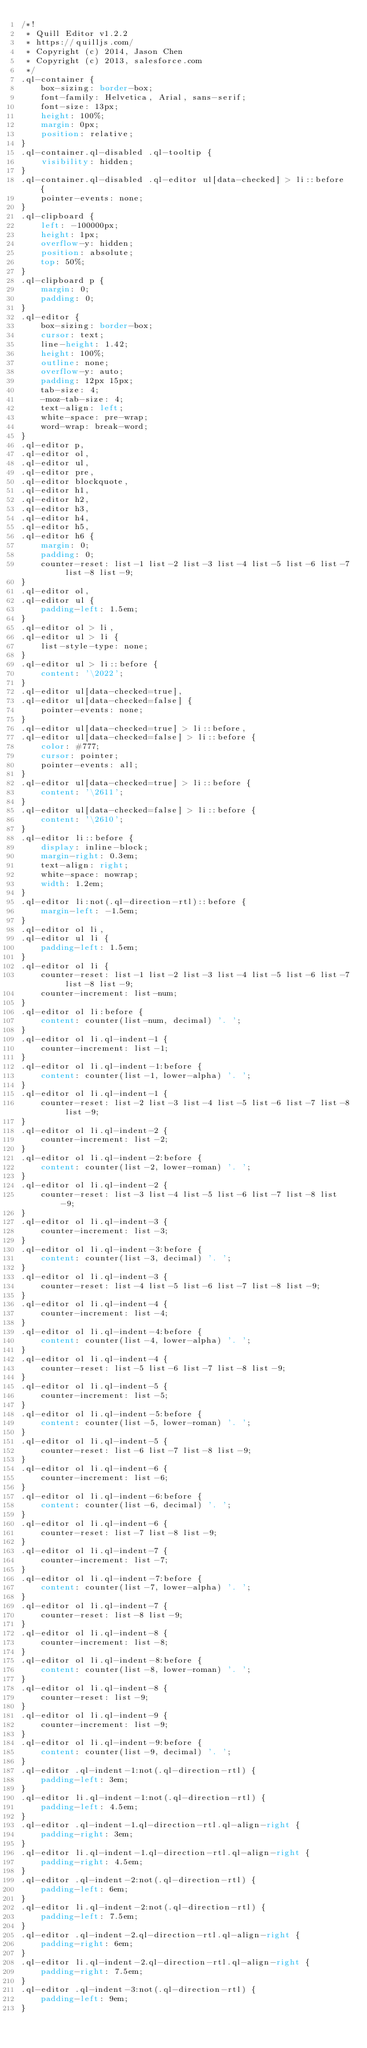<code> <loc_0><loc_0><loc_500><loc_500><_CSS_>/*!
 * Quill Editor v1.2.2
 * https://quilljs.com/
 * Copyright (c) 2014, Jason Chen
 * Copyright (c) 2013, salesforce.com
 */
.ql-container {
    box-sizing: border-box;
    font-family: Helvetica, Arial, sans-serif;
    font-size: 13px;
    height: 100%;
    margin: 0px;
    position: relative;
}
.ql-container.ql-disabled .ql-tooltip {
    visibility: hidden;
}
.ql-container.ql-disabled .ql-editor ul[data-checked] > li::before {
    pointer-events: none;
}
.ql-clipboard {
    left: -100000px;
    height: 1px;
    overflow-y: hidden;
    position: absolute;
    top: 50%;
}
.ql-clipboard p {
    margin: 0;
    padding: 0;
}
.ql-editor {
    box-sizing: border-box;
    cursor: text;
    line-height: 1.42;
    height: 100%;
    outline: none;
    overflow-y: auto;
    padding: 12px 15px;
    tab-size: 4;
    -moz-tab-size: 4;
    text-align: left;
    white-space: pre-wrap;
    word-wrap: break-word;
}
.ql-editor p,
.ql-editor ol,
.ql-editor ul,
.ql-editor pre,
.ql-editor blockquote,
.ql-editor h1,
.ql-editor h2,
.ql-editor h3,
.ql-editor h4,
.ql-editor h5,
.ql-editor h6 {
    margin: 0;
    padding: 0;
    counter-reset: list-1 list-2 list-3 list-4 list-5 list-6 list-7 list-8 list-9;
}
.ql-editor ol,
.ql-editor ul {
    padding-left: 1.5em;
}
.ql-editor ol > li,
.ql-editor ul > li {
    list-style-type: none;
}
.ql-editor ul > li::before {
    content: '\2022';
}
.ql-editor ul[data-checked=true],
.ql-editor ul[data-checked=false] {
    pointer-events: none;
}
.ql-editor ul[data-checked=true] > li::before,
.ql-editor ul[data-checked=false] > li::before {
    color: #777;
    cursor: pointer;
    pointer-events: all;
}
.ql-editor ul[data-checked=true] > li::before {
    content: '\2611';
}
.ql-editor ul[data-checked=false] > li::before {
    content: '\2610';
}
.ql-editor li::before {
    display: inline-block;
    margin-right: 0.3em;
    text-align: right;
    white-space: nowrap;
    width: 1.2em;
}
.ql-editor li:not(.ql-direction-rtl)::before {
    margin-left: -1.5em;
}
.ql-editor ol li,
.ql-editor ul li {
    padding-left: 1.5em;
}
.ql-editor ol li {
    counter-reset: list-1 list-2 list-3 list-4 list-5 list-6 list-7 list-8 list-9;
    counter-increment: list-num;
}
.ql-editor ol li:before {
    content: counter(list-num, decimal) '. ';
}
.ql-editor ol li.ql-indent-1 {
    counter-increment: list-1;
}
.ql-editor ol li.ql-indent-1:before {
    content: counter(list-1, lower-alpha) '. ';
}
.ql-editor ol li.ql-indent-1 {
    counter-reset: list-2 list-3 list-4 list-5 list-6 list-7 list-8 list-9;
}
.ql-editor ol li.ql-indent-2 {
    counter-increment: list-2;
}
.ql-editor ol li.ql-indent-2:before {
    content: counter(list-2, lower-roman) '. ';
}
.ql-editor ol li.ql-indent-2 {
    counter-reset: list-3 list-4 list-5 list-6 list-7 list-8 list-9;
}
.ql-editor ol li.ql-indent-3 {
    counter-increment: list-3;
}
.ql-editor ol li.ql-indent-3:before {
    content: counter(list-3, decimal) '. ';
}
.ql-editor ol li.ql-indent-3 {
    counter-reset: list-4 list-5 list-6 list-7 list-8 list-9;
}
.ql-editor ol li.ql-indent-4 {
    counter-increment: list-4;
}
.ql-editor ol li.ql-indent-4:before {
    content: counter(list-4, lower-alpha) '. ';
}
.ql-editor ol li.ql-indent-4 {
    counter-reset: list-5 list-6 list-7 list-8 list-9;
}
.ql-editor ol li.ql-indent-5 {
    counter-increment: list-5;
}
.ql-editor ol li.ql-indent-5:before {
    content: counter(list-5, lower-roman) '. ';
}
.ql-editor ol li.ql-indent-5 {
    counter-reset: list-6 list-7 list-8 list-9;
}
.ql-editor ol li.ql-indent-6 {
    counter-increment: list-6;
}
.ql-editor ol li.ql-indent-6:before {
    content: counter(list-6, decimal) '. ';
}
.ql-editor ol li.ql-indent-6 {
    counter-reset: list-7 list-8 list-9;
}
.ql-editor ol li.ql-indent-7 {
    counter-increment: list-7;
}
.ql-editor ol li.ql-indent-7:before {
    content: counter(list-7, lower-alpha) '. ';
}
.ql-editor ol li.ql-indent-7 {
    counter-reset: list-8 list-9;
}
.ql-editor ol li.ql-indent-8 {
    counter-increment: list-8;
}
.ql-editor ol li.ql-indent-8:before {
    content: counter(list-8, lower-roman) '. ';
}
.ql-editor ol li.ql-indent-8 {
    counter-reset: list-9;
}
.ql-editor ol li.ql-indent-9 {
    counter-increment: list-9;
}
.ql-editor ol li.ql-indent-9:before {
    content: counter(list-9, decimal) '. ';
}
.ql-editor .ql-indent-1:not(.ql-direction-rtl) {
    padding-left: 3em;
}
.ql-editor li.ql-indent-1:not(.ql-direction-rtl) {
    padding-left: 4.5em;
}
.ql-editor .ql-indent-1.ql-direction-rtl.ql-align-right {
    padding-right: 3em;
}
.ql-editor li.ql-indent-1.ql-direction-rtl.ql-align-right {
    padding-right: 4.5em;
}
.ql-editor .ql-indent-2:not(.ql-direction-rtl) {
    padding-left: 6em;
}
.ql-editor li.ql-indent-2:not(.ql-direction-rtl) {
    padding-left: 7.5em;
}
.ql-editor .ql-indent-2.ql-direction-rtl.ql-align-right {
    padding-right: 6em;
}
.ql-editor li.ql-indent-2.ql-direction-rtl.ql-align-right {
    padding-right: 7.5em;
}
.ql-editor .ql-indent-3:not(.ql-direction-rtl) {
    padding-left: 9em;
}</code> 